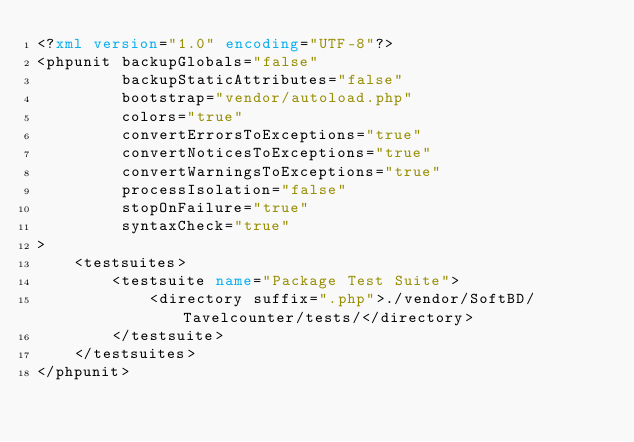Convert code to text. <code><loc_0><loc_0><loc_500><loc_500><_XML_><?xml version="1.0" encoding="UTF-8"?>
<phpunit backupGlobals="false"
         backupStaticAttributes="false"
         bootstrap="vendor/autoload.php"
         colors="true"
         convertErrorsToExceptions="true"
         convertNoticesToExceptions="true"
         convertWarningsToExceptions="true"
         processIsolation="false"
         stopOnFailure="true"
         syntaxCheck="true"
>
    <testsuites>
        <testsuite name="Package Test Suite">
            <directory suffix=".php">./vendor/SoftBD/Tavelcounter/tests/</directory>
        </testsuite>
    </testsuites>
</phpunit></code> 